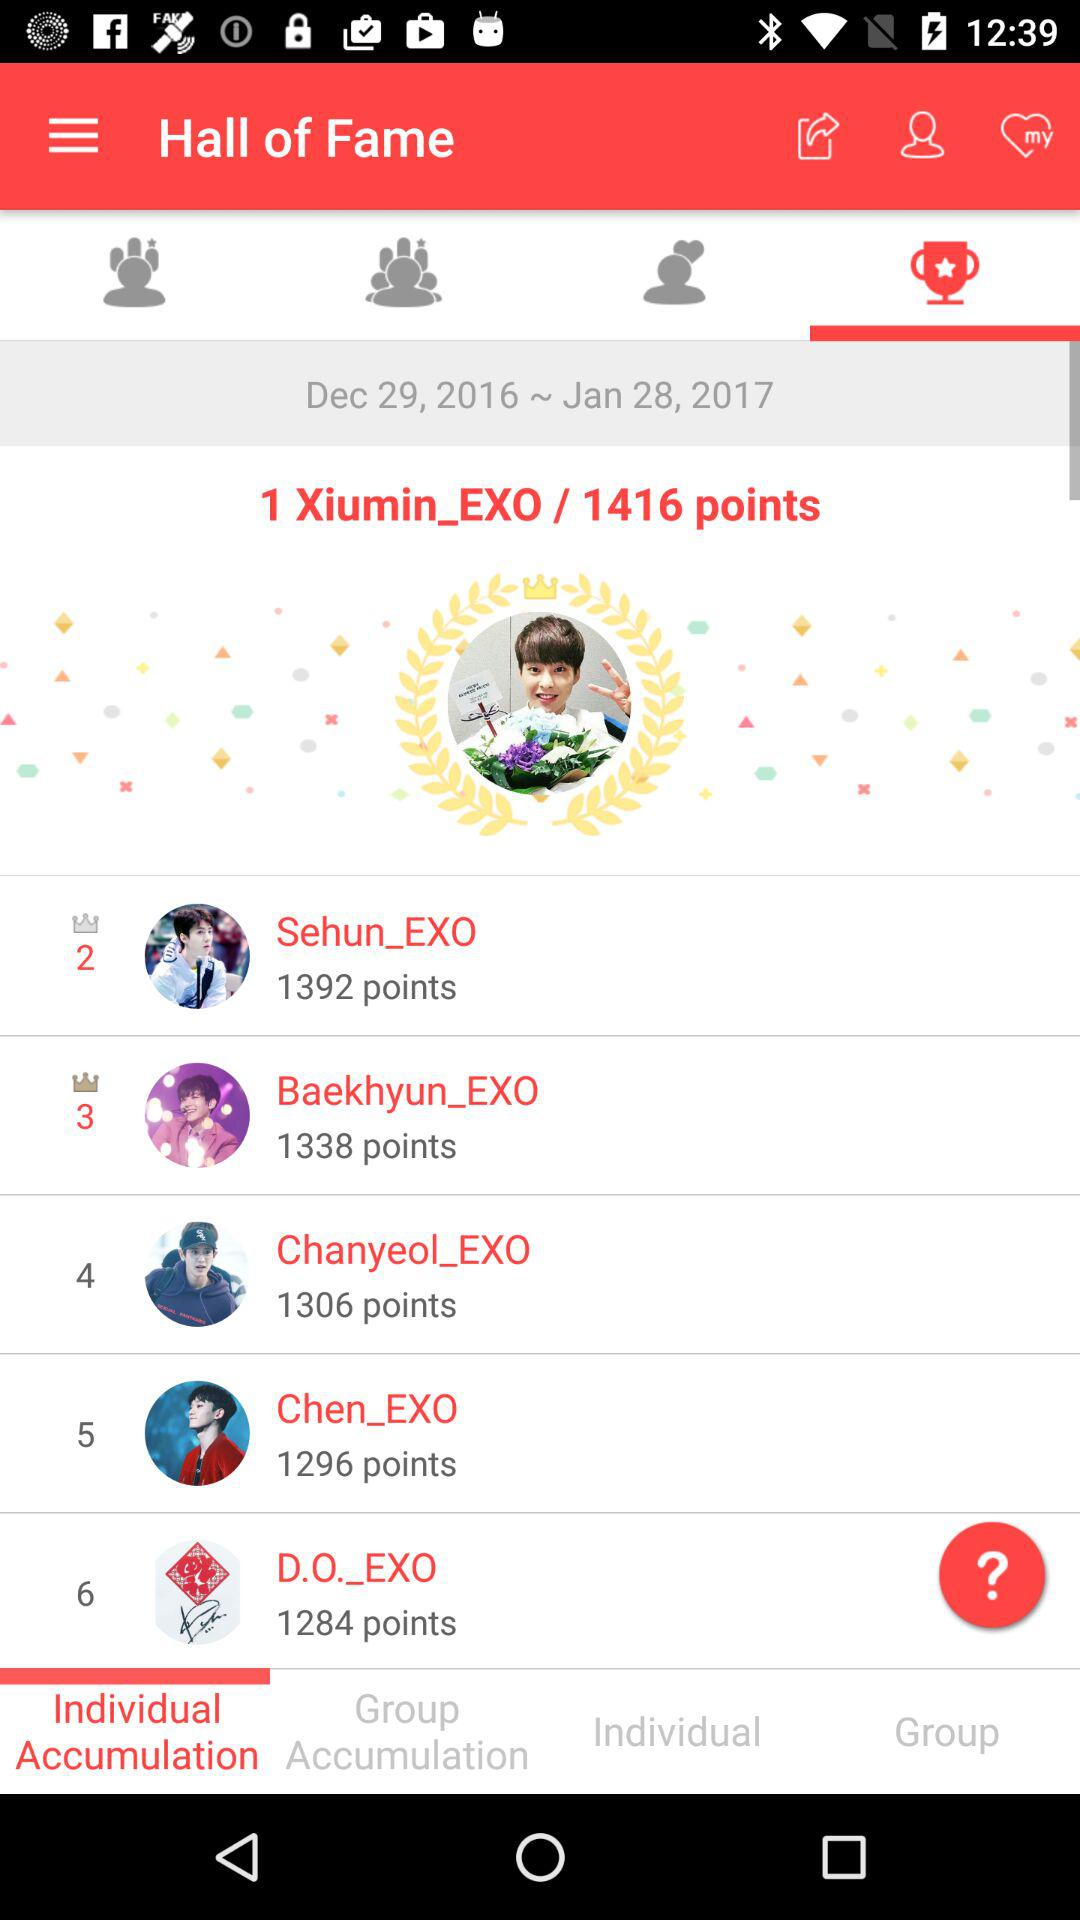What year is mentioned in the period? The years mentioned in the period are 2016 and 2017. 